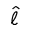Convert formula to latex. <formula><loc_0><loc_0><loc_500><loc_500>\hat { \ell }</formula> 